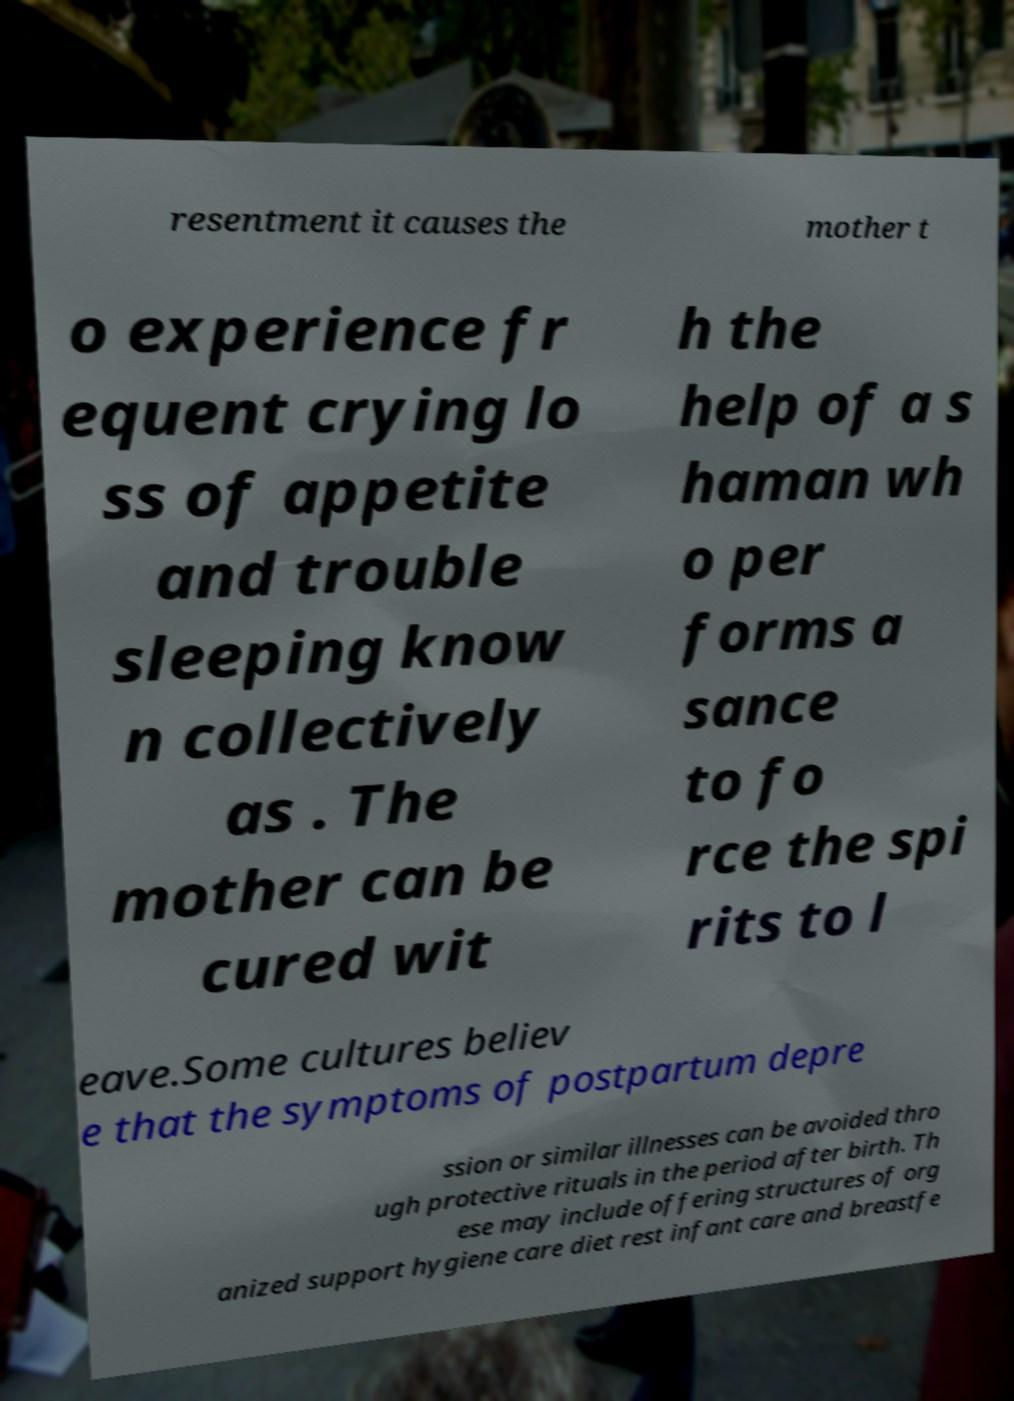Can you accurately transcribe the text from the provided image for me? resentment it causes the mother t o experience fr equent crying lo ss of appetite and trouble sleeping know n collectively as . The mother can be cured wit h the help of a s haman wh o per forms a sance to fo rce the spi rits to l eave.Some cultures believ e that the symptoms of postpartum depre ssion or similar illnesses can be avoided thro ugh protective rituals in the period after birth. Th ese may include offering structures of org anized support hygiene care diet rest infant care and breastfe 